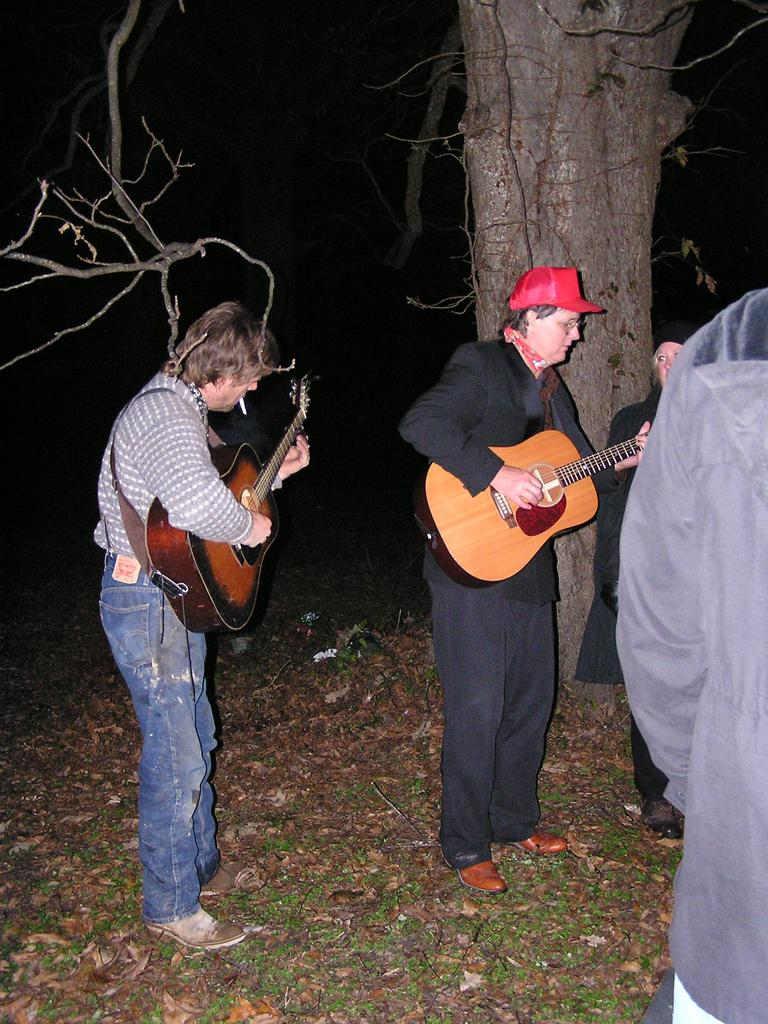How many people are playing a guitar in the image? There are two persons standing in the image, and both are playing a guitar. What else can be seen in the image besides the guitar players? There are other persons in the image. What is visible in the background of the image? There is a tree in the background of the image. What is the title of the song being played by the guitarists in the image? There is no information about the song being played in the image, so we cannot determine its title. 